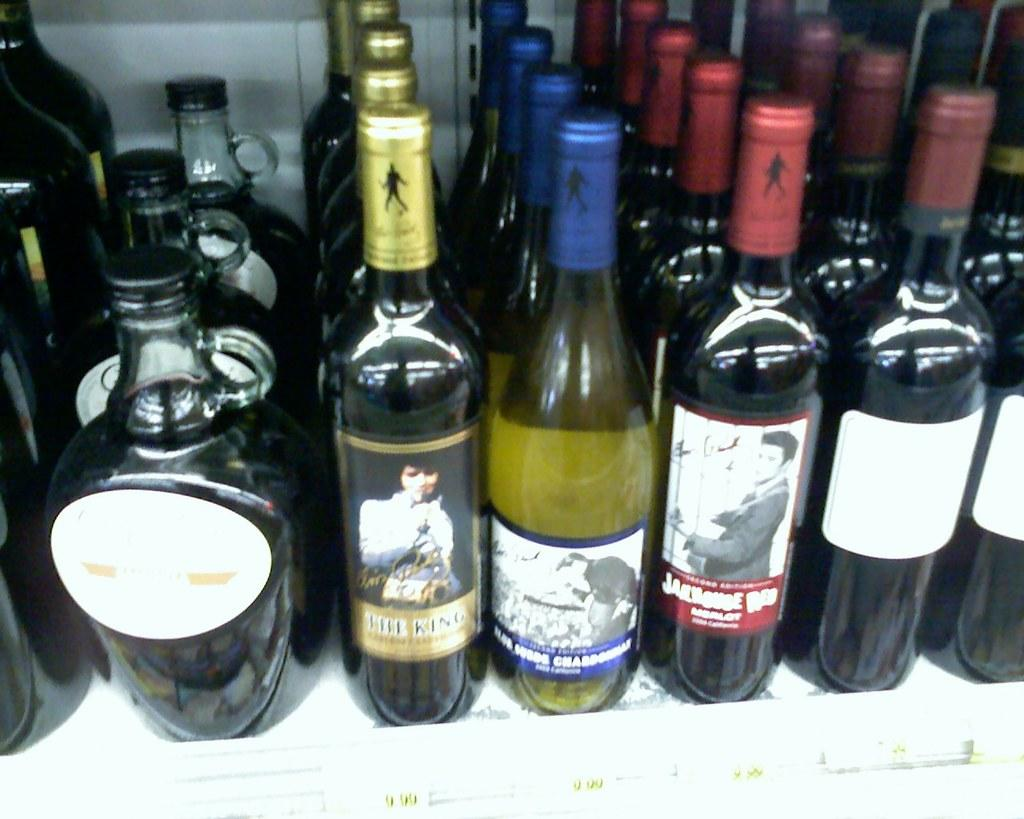What is the primary subject of the image? The primary subject of the image is many bottles. Can you describe the position of a specific bottle in the image? Yes, there is a bottle in the middle of the image. What distinguishes the middle bottle from the others? The middle bottle has a label with written text. How does the sock move around in the image? There is no sock present in the image; it only features many bottles. 